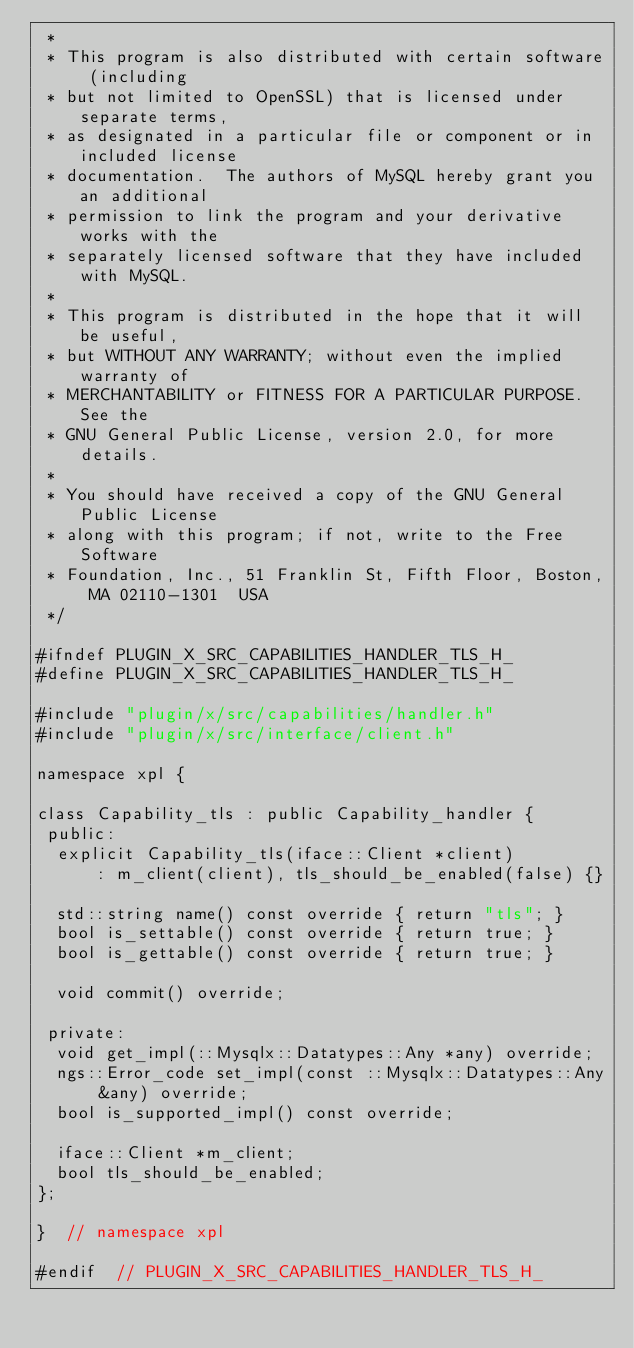Convert code to text. <code><loc_0><loc_0><loc_500><loc_500><_C_> *
 * This program is also distributed with certain software (including
 * but not limited to OpenSSL) that is licensed under separate terms,
 * as designated in a particular file or component or in included license
 * documentation.  The authors of MySQL hereby grant you an additional
 * permission to link the program and your derivative works with the
 * separately licensed software that they have included with MySQL.
 *
 * This program is distributed in the hope that it will be useful,
 * but WITHOUT ANY WARRANTY; without even the implied warranty of
 * MERCHANTABILITY or FITNESS FOR A PARTICULAR PURPOSE.  See the
 * GNU General Public License, version 2.0, for more details.
 *
 * You should have received a copy of the GNU General Public License
 * along with this program; if not, write to the Free Software
 * Foundation, Inc., 51 Franklin St, Fifth Floor, Boston, MA 02110-1301  USA
 */

#ifndef PLUGIN_X_SRC_CAPABILITIES_HANDLER_TLS_H_
#define PLUGIN_X_SRC_CAPABILITIES_HANDLER_TLS_H_

#include "plugin/x/src/capabilities/handler.h"
#include "plugin/x/src/interface/client.h"

namespace xpl {

class Capability_tls : public Capability_handler {
 public:
  explicit Capability_tls(iface::Client *client)
      : m_client(client), tls_should_be_enabled(false) {}

  std::string name() const override { return "tls"; }
  bool is_settable() const override { return true; }
  bool is_gettable() const override { return true; }

  void commit() override;

 private:
  void get_impl(::Mysqlx::Datatypes::Any *any) override;
  ngs::Error_code set_impl(const ::Mysqlx::Datatypes::Any &any) override;
  bool is_supported_impl() const override;

  iface::Client *m_client;
  bool tls_should_be_enabled;
};

}  // namespace xpl

#endif  // PLUGIN_X_SRC_CAPABILITIES_HANDLER_TLS_H_
</code> 